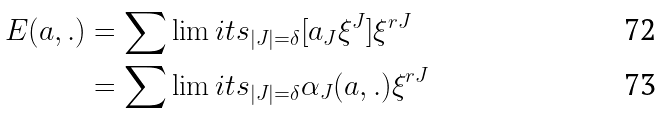Convert formula to latex. <formula><loc_0><loc_0><loc_500><loc_500>E ( a , . ) & = \sum \lim i t s _ { | J | = \delta } [ a _ { J } \xi ^ { J } ] \xi ^ { r J } \\ & = \sum \lim i t s _ { | J | = \delta } \alpha _ { J } ( a , . ) \xi ^ { r J }</formula> 